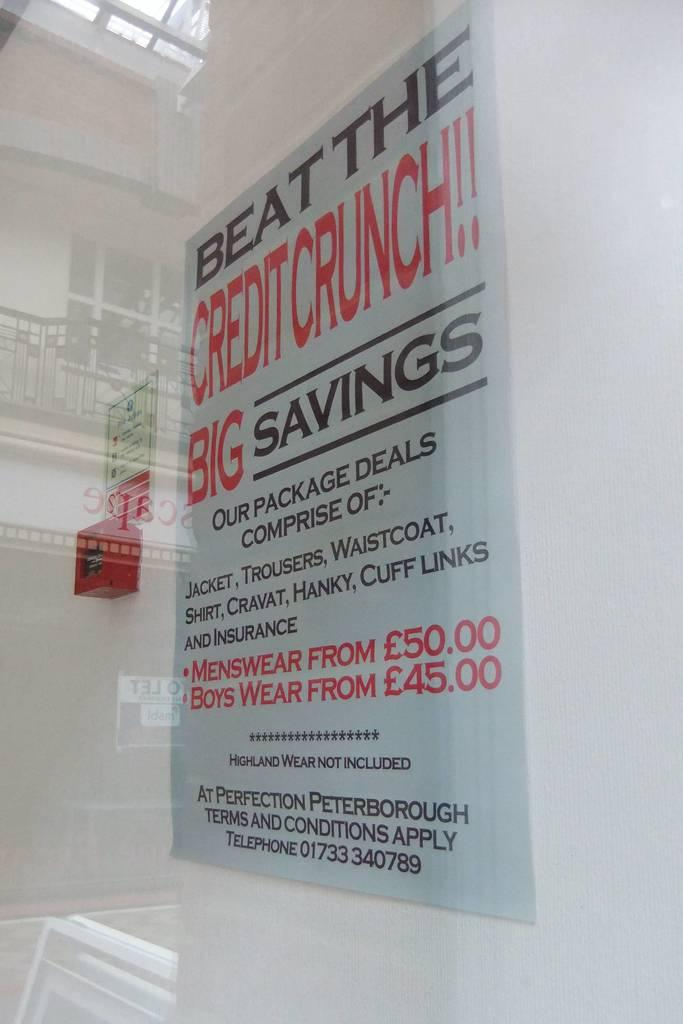<image>
Render a clear and concise summary of the photo. A sign that advertises savings at Perfection Peterborough. 